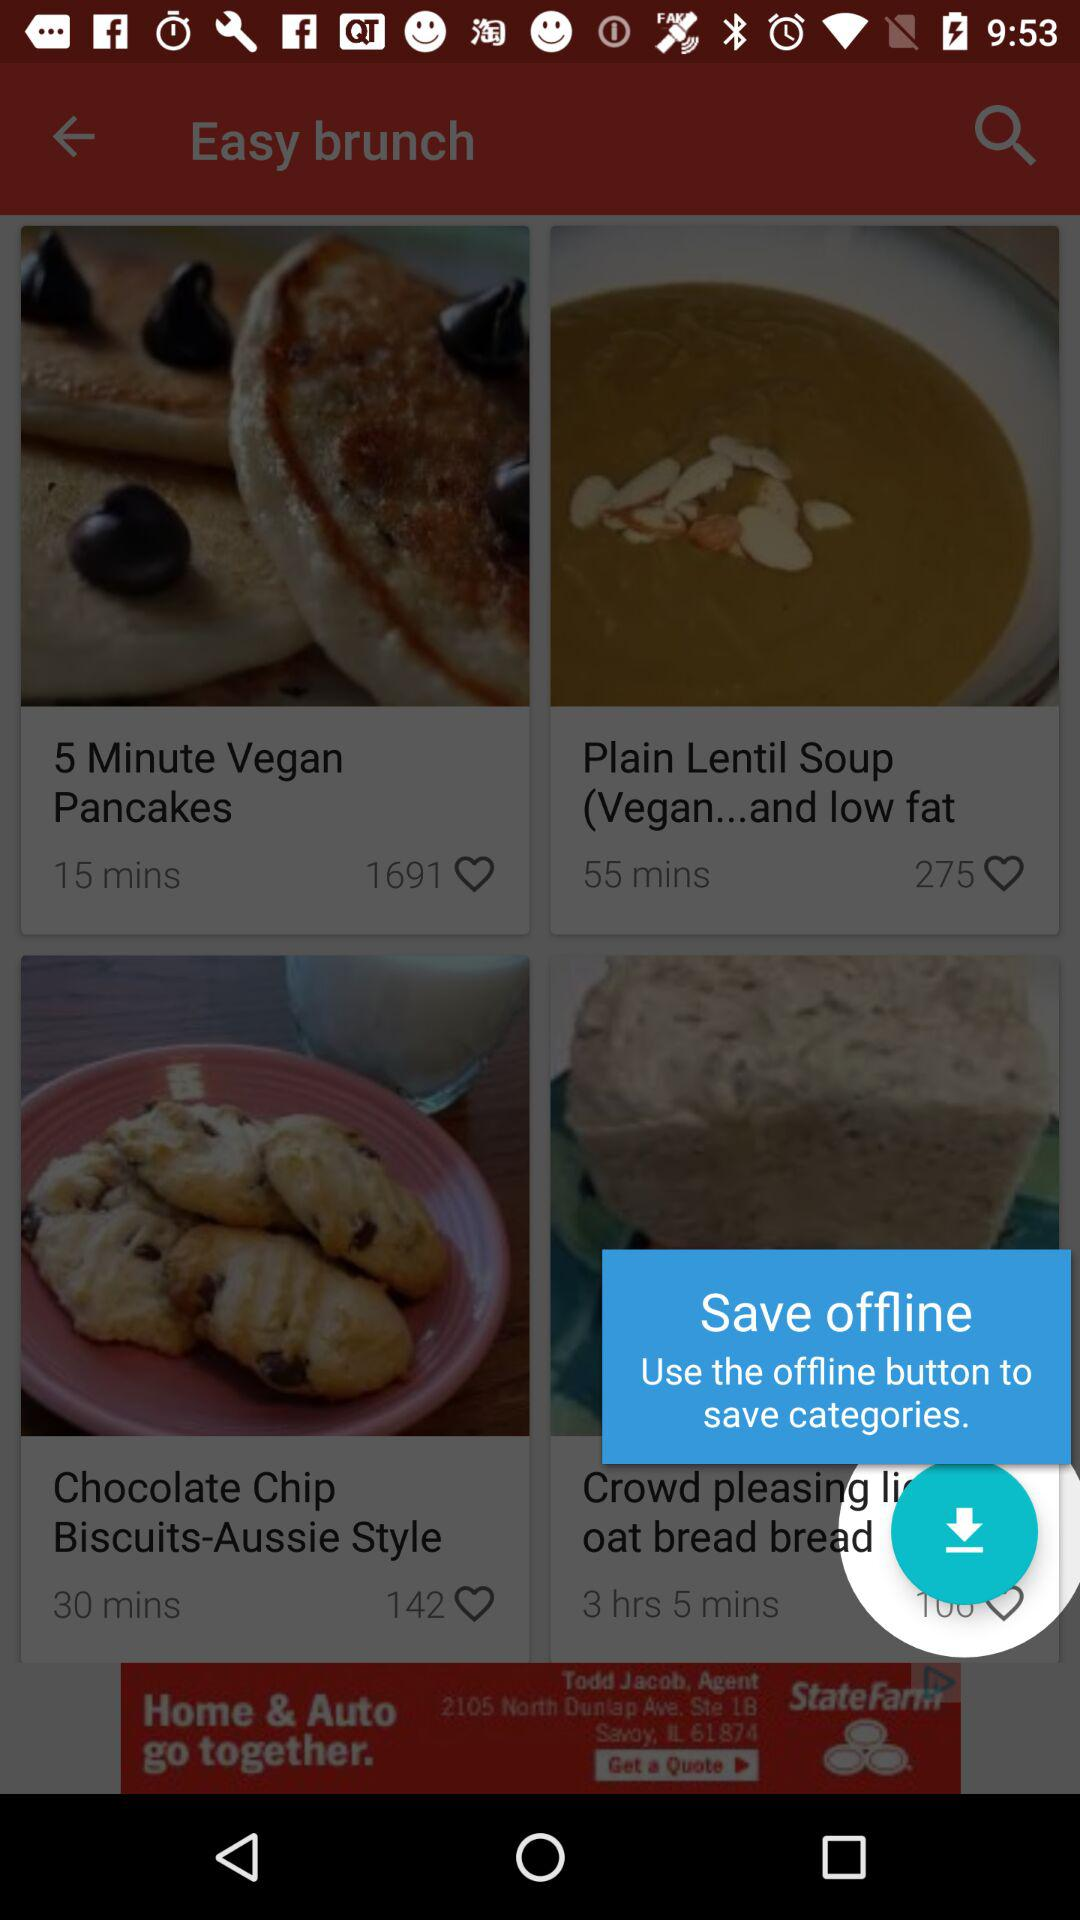What button is used to save the categories? The button that is used to save the categories is "offline". 